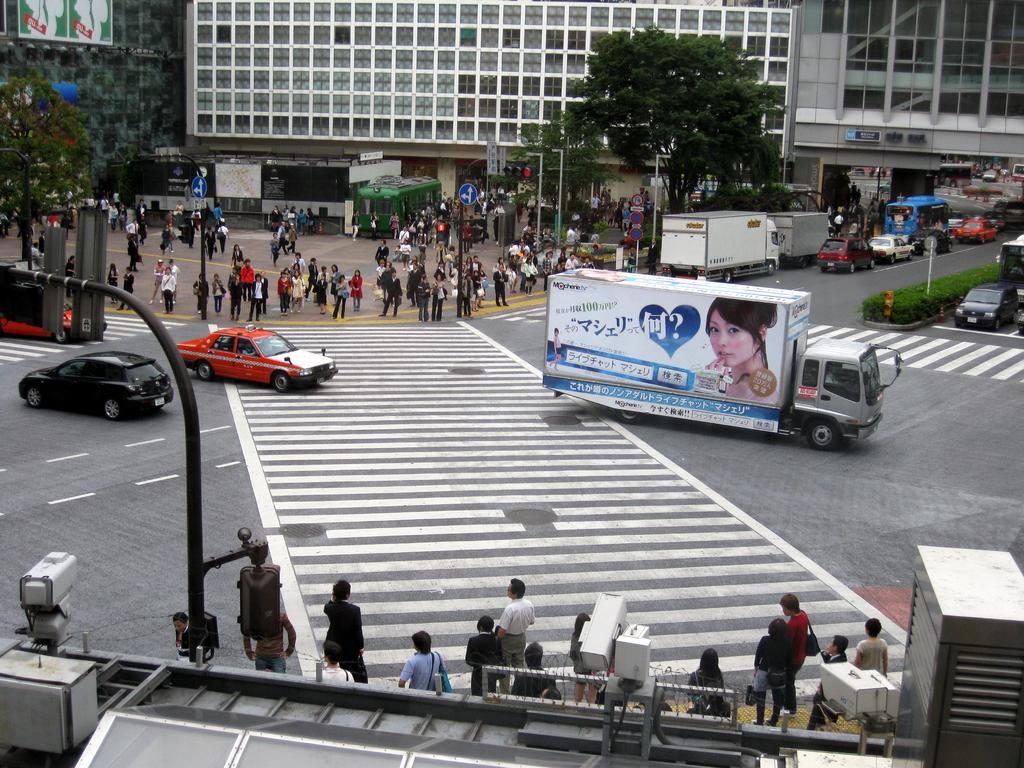What can be seen on the road in the image? There are vehicles on the road in the image. What are the people in the image doing? There are people standing in the image. What type of signs are present in the image? There are signal boards in the image. What structures are present for illumination in the image? There are light poles in the image. What type of vegetation is present in the image? There are trees in the image. What type of man-made structures are present in the image? There are buildings in the image. What type of plants are present in the image? There are bushes in the image. What type of surveillance equipment is present in the image? There are cameras in the image. What type of advertising is present in the image? There are billboards in the image. Where is the apple shelf located in the image? There is no apple shelf present in the image. What type of wilderness can be seen in the image? There is no wilderness present in the image; it features urban elements such as vehicles, people, signal boards, light poles, trees, buildings, bushes, cameras, and billboards. 